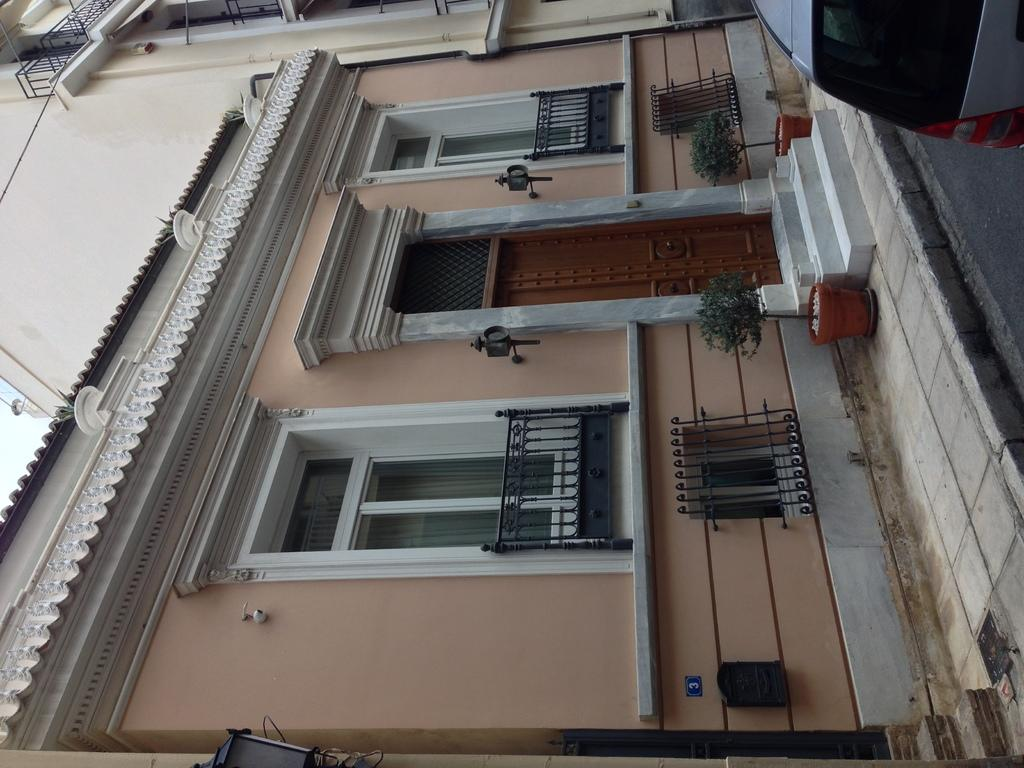What type of structure is visible in the image? There is a building in the image. What features can be seen on the building? The building has windows, a door, and stairs. Are there any plants visible in the image? Yes, there are pots with plants in the image. What type of lighting is present in the image? There is a street lamp in the image. Is there any transportation visible in the image? Yes, there is a car on the road in the image. Can you see a kitty playing with a hand in the image? There is no kitty or hand present in the image. What suggestion is being made by the building in the image? Buildings do not make suggestions; they are inanimate structures. 